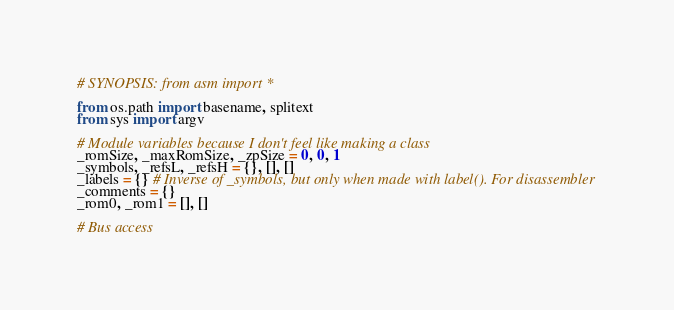<code> <loc_0><loc_0><loc_500><loc_500><_Python_>
# SYNOPSIS: from asm import *

from os.path import basename, splitext
from sys import argv

# Module variables because I don't feel like making a class
_romSize, _maxRomSize, _zpSize = 0, 0, 1
_symbols, _refsL, _refsH = {}, [], []
_labels = {} # Inverse of _symbols, but only when made with label(). For disassembler
_comments = {}
_rom0, _rom1 = [], []

# Bus access</code> 